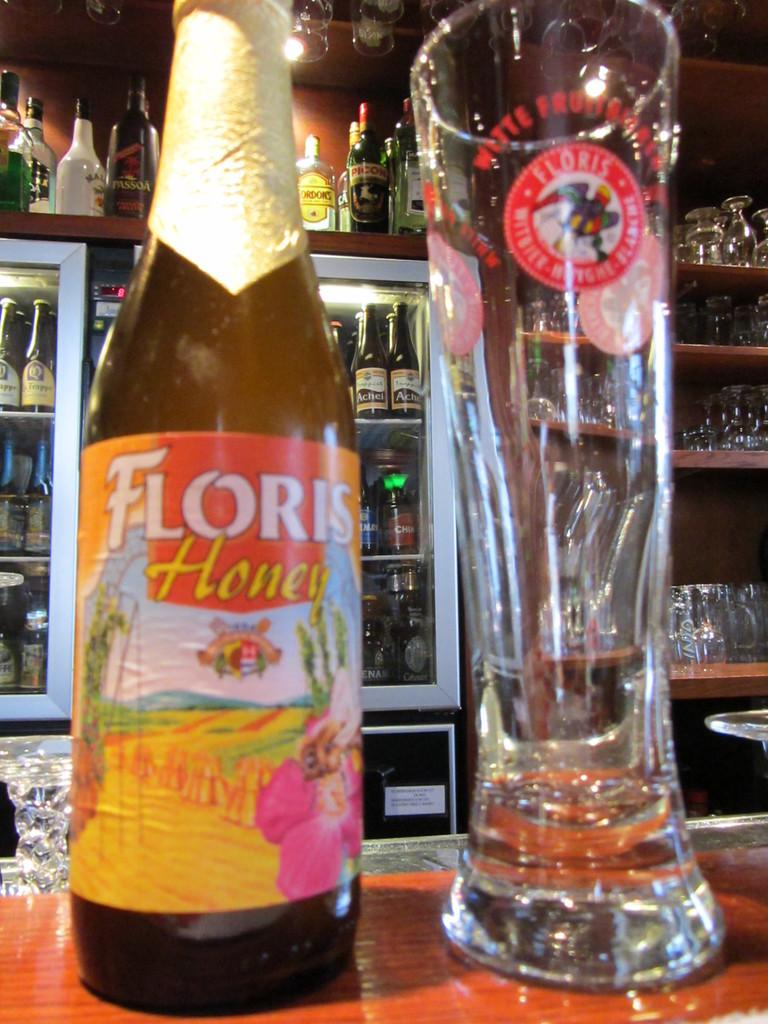Provide a one-sentence caption for the provided image. A bottle labeled Floris Honey is next to a large glass. 